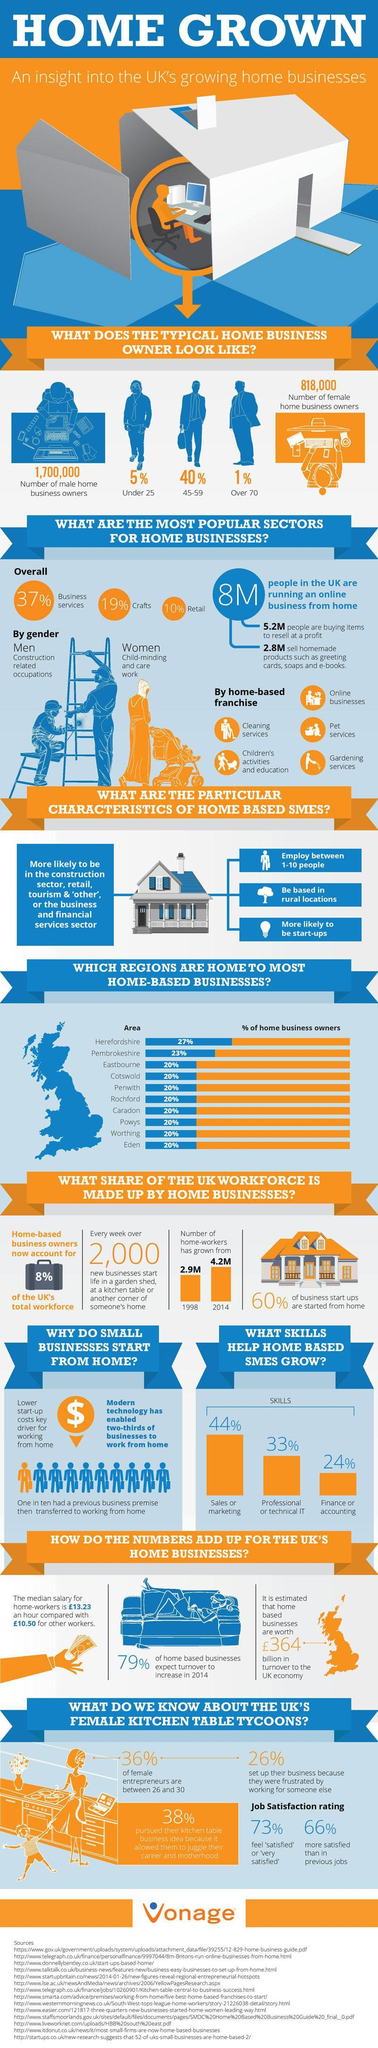What are the top three skills that help home business?
Answer the question with a short phrase. sales or marketing, professional or technical IT, finance or accounting What is the percentage of female entrepreneurs who is less satisfied than in previous job? 34% Which age group is more active as home business owner - under 25 or over 70? under 25 What is the percentage of female entrepreneurs who doesn't belong to the age group of 26-30? 64 What is the percentage of people who sell homemade products among online home business? 35% What is the difference between the number of male and female home business owners? 882000 Increase in the number of home workers from 1998 to 2014 (in millions) is? 1.3 Which category more involved in home business - male or female? male Which are the three sectors of business that covers 66% of the entire home business? Business services, crafts, retail which is higher - median salary for home workers or others? median salary for home workers What is the percentage of people who are buying items to resell among online home business? 65% 